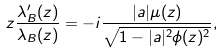<formula> <loc_0><loc_0><loc_500><loc_500>z \frac { \lambda _ { B } ^ { \prime } ( z ) } { \lambda _ { B } ( z ) } = - i \frac { | a | \mu ( z ) } { \sqrt { 1 - | a | ^ { 2 } \phi ( z ) ^ { 2 } } } ,</formula> 